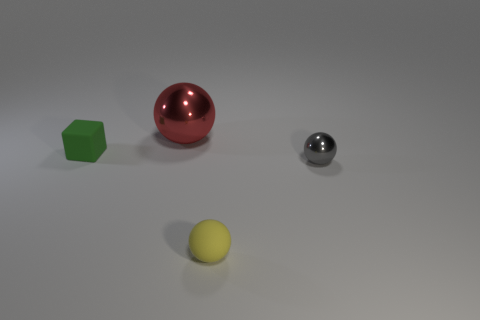Subtract all purple balls. Subtract all yellow blocks. How many balls are left? 3 Add 4 gray shiny things. How many objects exist? 8 Subtract all blocks. How many objects are left? 3 Add 2 tiny purple cubes. How many tiny purple cubes exist? 2 Subtract 0 gray cubes. How many objects are left? 4 Subtract all tiny gray things. Subtract all spheres. How many objects are left? 0 Add 4 yellow balls. How many yellow balls are left? 5 